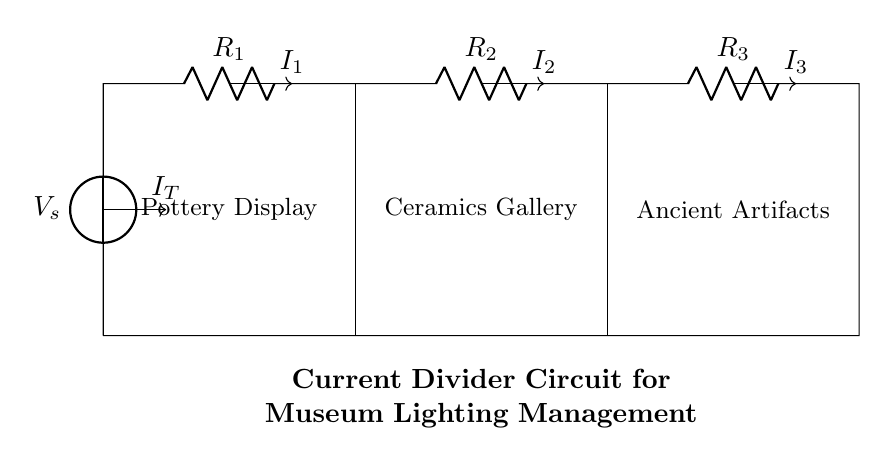What is the total supplied voltage in this circuit? The total supplied voltage is the voltage of the source labeled V_s, which is directly stated in the diagram.
Answer: V_s How many resistors are connected in this circuit? The circuit diagram shows three resistors labeled R_1, R_2, and R_3 connected in series. Counting these, we find a total of three resistors.
Answer: 3 What is the division of current in this circuit? The currents I_1, I_2, and I_3 each represent the current flowing through R_1, R_2, and R_3 respectively. The specific values are not provided, but each current can be determined based on the resistance values and the total current I_T.
Answer: I_1, I_2, I_3 Which area of the museum does the current I_2 feed? Referring to the circuit diagram, current I_2 is directed towards the node indicated for the "Ceramics Gallery." Thus, it is responsible for powering this area.
Answer: Ceramics Gallery Describe how the current is divided among the components. The current divider principle dictates that the total current supplied (I_T) is divided among the resistors based on their resistance values. The current through each resistor is inversely proportional to its resistance; thus, lower resistance allows a higher current to flow. This is a fundamental aspect of the current division more complex reasoning based on Ohm's law.
Answer: By resistance values 